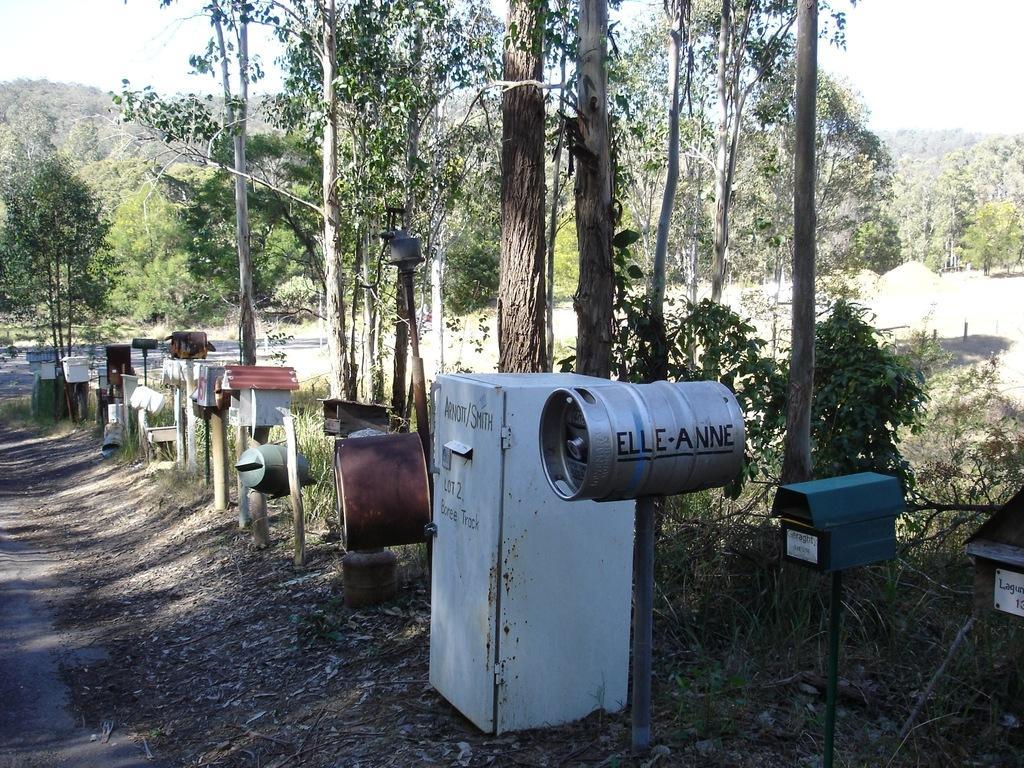Could you give a brief overview of what you see in this image? In this image we can see furnaces placed on the ground. In addition to these we can see shredded leaves on the ground, plants, trees and sky in the background. 